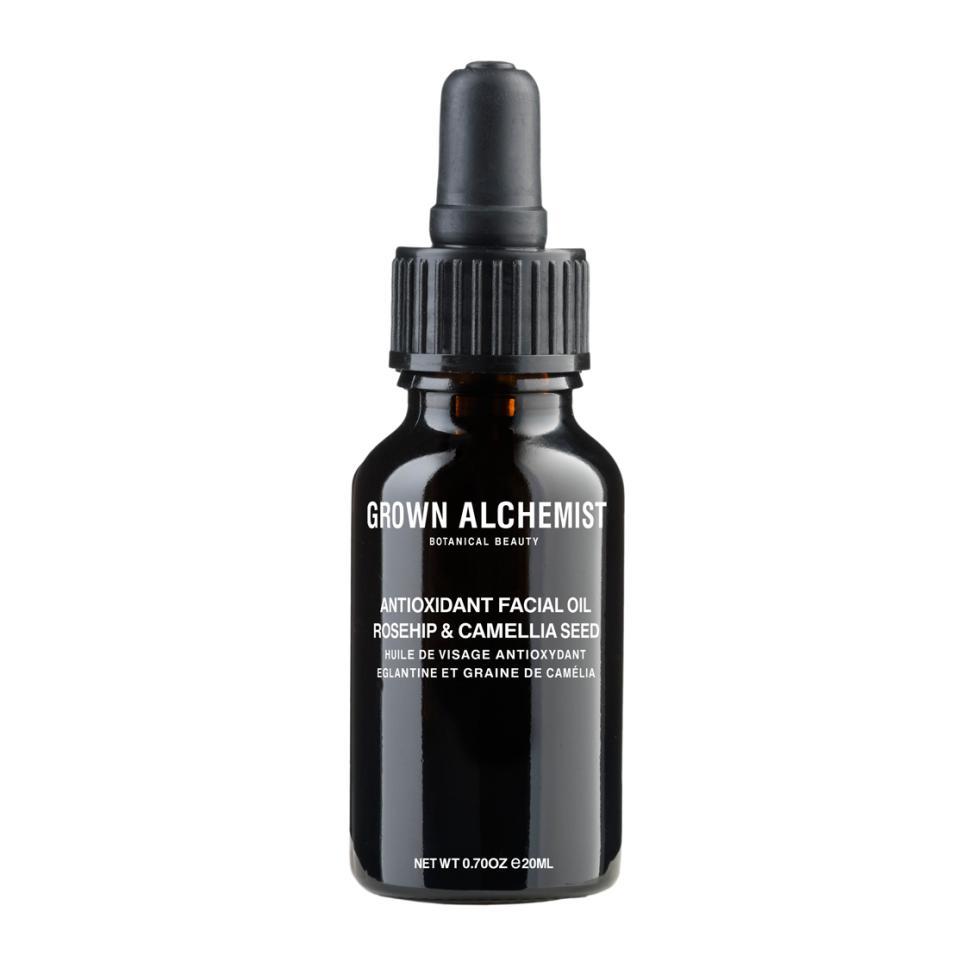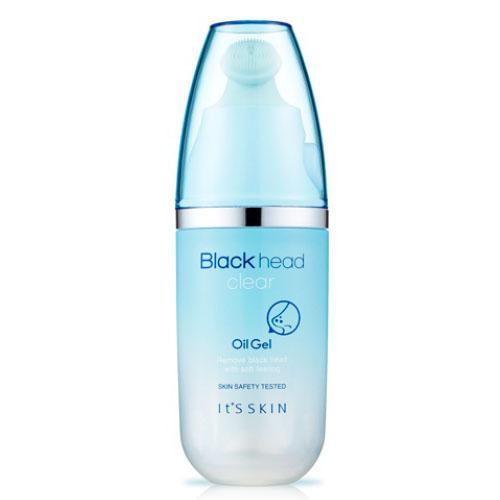The first image is the image on the left, the second image is the image on the right. Examine the images to the left and right. Is the description "A wide product box with pink writing are in both images." accurate? Answer yes or no. No. The first image is the image on the left, the second image is the image on the right. Examine the images to the left and right. Is the description "There is at least one bottle with no box or bag." accurate? Answer yes or no. Yes. 